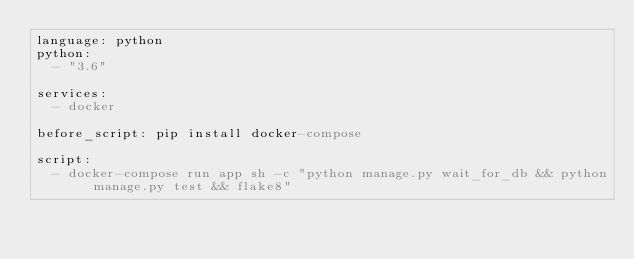<code> <loc_0><loc_0><loc_500><loc_500><_YAML_>language: python
python:
  - "3.6"

services: 
  - docker

before_script: pip install docker-compose

script:
  - docker-compose run app sh -c "python manage.py wait_for_db && python manage.py test && flake8"
</code> 